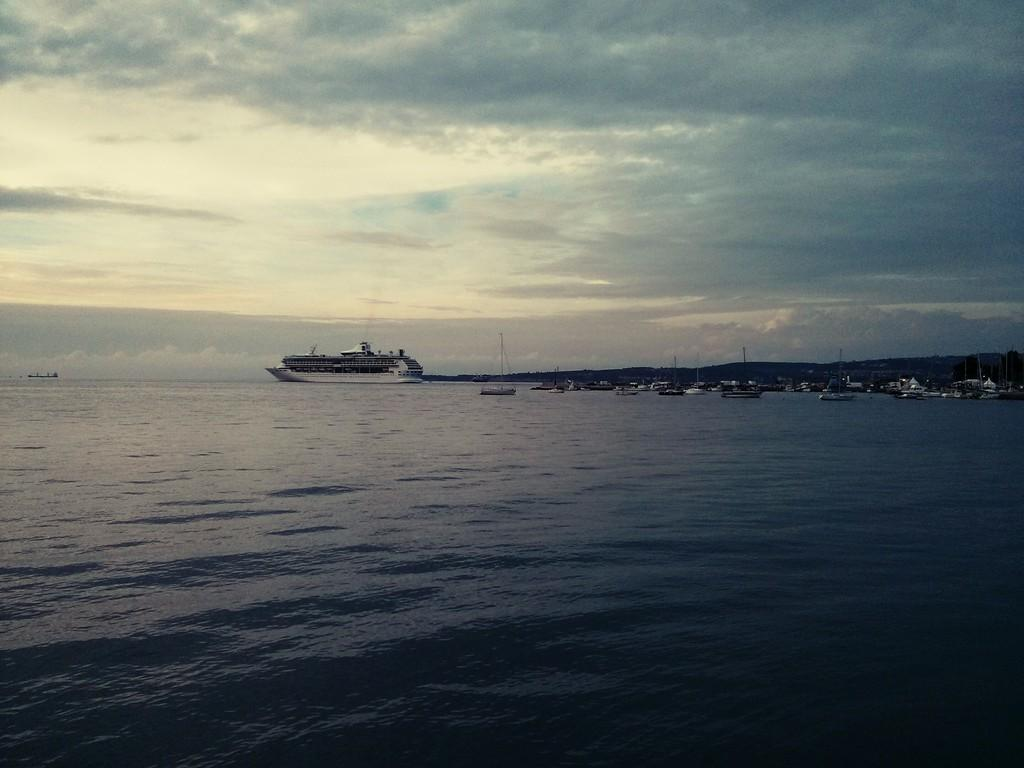What type of watercraft can be seen in the image? There are boats and a ship in the image. Where are the boats and ship located? They are on the surface of a river. What can be seen in the background of the image? There is a sky visible in the background of the image. What is present in the sky? Clouds are present in the sky. How many girls are sitting on the toad in the image? There are no girls or toads present in the image. What is the temperature like in the image? The provided facts do not mention the temperature or heat in the image. 